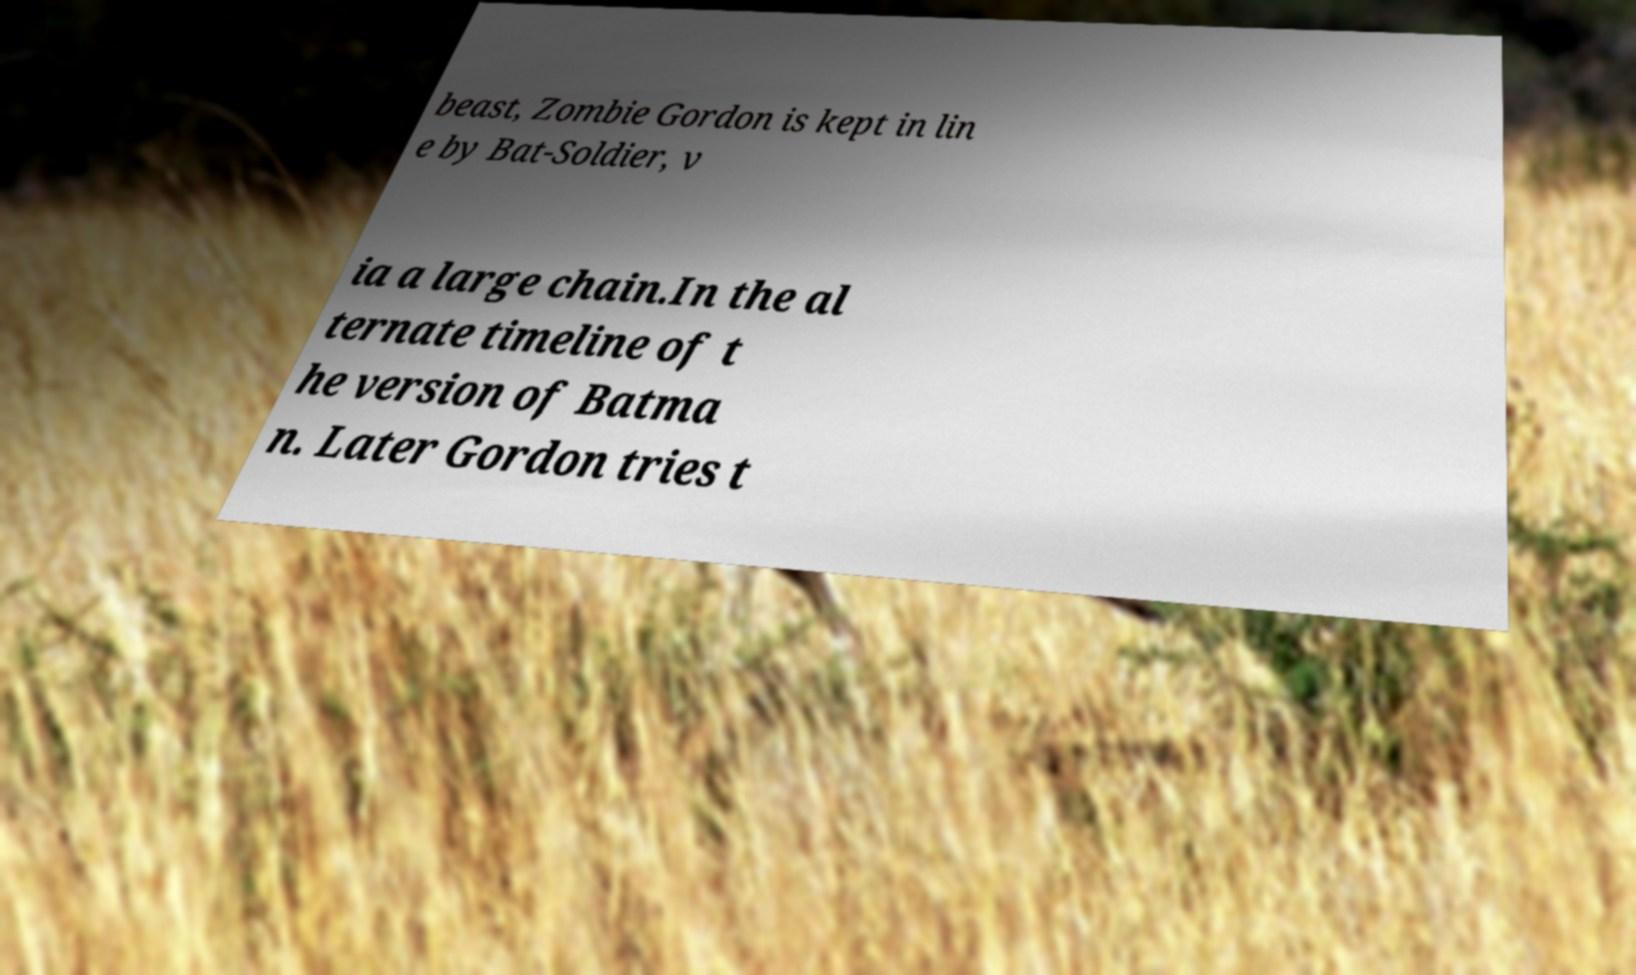For documentation purposes, I need the text within this image transcribed. Could you provide that? beast, Zombie Gordon is kept in lin e by Bat-Soldier, v ia a large chain.In the al ternate timeline of t he version of Batma n. Later Gordon tries t 